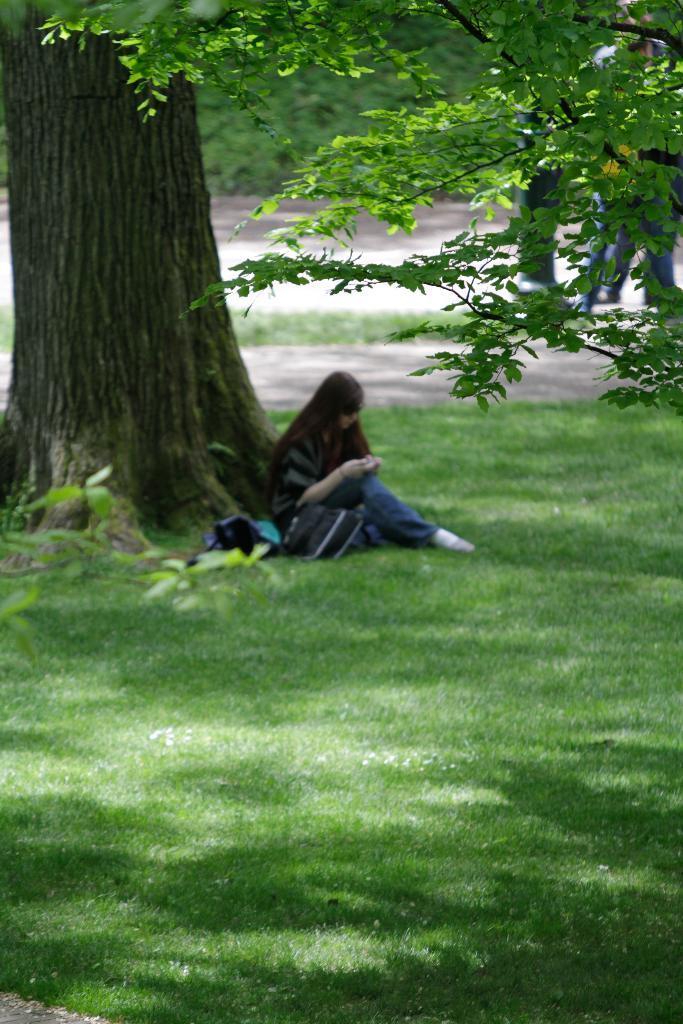Please provide a concise description of this image. Here we can see a woman sitting on the ground and there is a bag. This is grass and there are trees. Here we can see few persons on the road. 